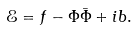Convert formula to latex. <formula><loc_0><loc_0><loc_500><loc_500>\mathcal { E } = f - \Phi \bar { \Phi } + i b .</formula> 